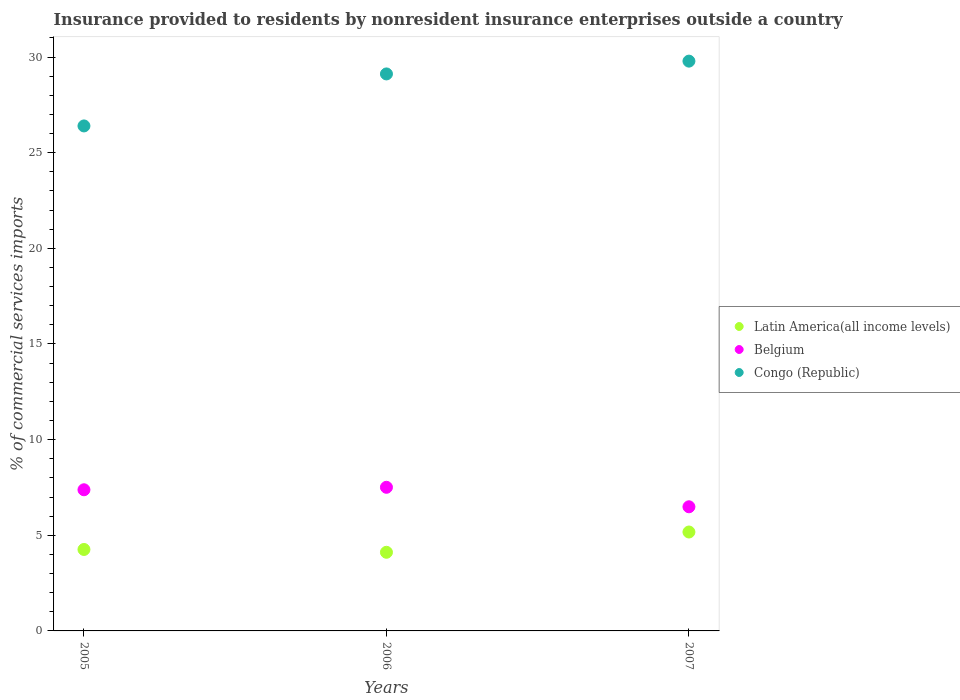How many different coloured dotlines are there?
Provide a short and direct response. 3. Is the number of dotlines equal to the number of legend labels?
Offer a terse response. Yes. What is the Insurance provided to residents in Latin America(all income levels) in 2005?
Your answer should be very brief. 4.26. Across all years, what is the maximum Insurance provided to residents in Belgium?
Your answer should be compact. 7.51. Across all years, what is the minimum Insurance provided to residents in Latin America(all income levels)?
Make the answer very short. 4.11. In which year was the Insurance provided to residents in Latin America(all income levels) maximum?
Provide a short and direct response. 2007. In which year was the Insurance provided to residents in Latin America(all income levels) minimum?
Keep it short and to the point. 2006. What is the total Insurance provided to residents in Congo (Republic) in the graph?
Your answer should be compact. 85.3. What is the difference between the Insurance provided to residents in Belgium in 2005 and that in 2007?
Your answer should be compact. 0.89. What is the difference between the Insurance provided to residents in Congo (Republic) in 2006 and the Insurance provided to residents in Latin America(all income levels) in 2005?
Offer a very short reply. 24.86. What is the average Insurance provided to residents in Belgium per year?
Make the answer very short. 7.13. In the year 2007, what is the difference between the Insurance provided to residents in Congo (Republic) and Insurance provided to residents in Latin America(all income levels)?
Your answer should be compact. 24.61. What is the ratio of the Insurance provided to residents in Latin America(all income levels) in 2005 to that in 2006?
Offer a very short reply. 1.04. What is the difference between the highest and the second highest Insurance provided to residents in Belgium?
Provide a short and direct response. 0.13. What is the difference between the highest and the lowest Insurance provided to residents in Latin America(all income levels)?
Make the answer very short. 1.06. In how many years, is the Insurance provided to residents in Congo (Republic) greater than the average Insurance provided to residents in Congo (Republic) taken over all years?
Provide a succinct answer. 2. Is the sum of the Insurance provided to residents in Congo (Republic) in 2005 and 2007 greater than the maximum Insurance provided to residents in Belgium across all years?
Offer a terse response. Yes. Is it the case that in every year, the sum of the Insurance provided to residents in Belgium and Insurance provided to residents in Latin America(all income levels)  is greater than the Insurance provided to residents in Congo (Republic)?
Make the answer very short. No. Is the Insurance provided to residents in Belgium strictly greater than the Insurance provided to residents in Congo (Republic) over the years?
Offer a terse response. No. Is the Insurance provided to residents in Latin America(all income levels) strictly less than the Insurance provided to residents in Congo (Republic) over the years?
Your answer should be compact. Yes. How many years are there in the graph?
Provide a succinct answer. 3. Are the values on the major ticks of Y-axis written in scientific E-notation?
Your answer should be compact. No. How many legend labels are there?
Your answer should be very brief. 3. What is the title of the graph?
Keep it short and to the point. Insurance provided to residents by nonresident insurance enterprises outside a country. Does "Micronesia" appear as one of the legend labels in the graph?
Offer a very short reply. No. What is the label or title of the X-axis?
Your answer should be very brief. Years. What is the label or title of the Y-axis?
Keep it short and to the point. % of commercial services imports. What is the % of commercial services imports in Latin America(all income levels) in 2005?
Your response must be concise. 4.26. What is the % of commercial services imports of Belgium in 2005?
Keep it short and to the point. 7.38. What is the % of commercial services imports in Congo (Republic) in 2005?
Offer a terse response. 26.4. What is the % of commercial services imports of Latin America(all income levels) in 2006?
Keep it short and to the point. 4.11. What is the % of commercial services imports of Belgium in 2006?
Make the answer very short. 7.51. What is the % of commercial services imports of Congo (Republic) in 2006?
Your answer should be compact. 29.12. What is the % of commercial services imports of Latin America(all income levels) in 2007?
Offer a very short reply. 5.17. What is the % of commercial services imports in Belgium in 2007?
Keep it short and to the point. 6.49. What is the % of commercial services imports in Congo (Republic) in 2007?
Offer a terse response. 29.78. Across all years, what is the maximum % of commercial services imports of Latin America(all income levels)?
Provide a short and direct response. 5.17. Across all years, what is the maximum % of commercial services imports in Belgium?
Give a very brief answer. 7.51. Across all years, what is the maximum % of commercial services imports of Congo (Republic)?
Your answer should be compact. 29.78. Across all years, what is the minimum % of commercial services imports in Latin America(all income levels)?
Keep it short and to the point. 4.11. Across all years, what is the minimum % of commercial services imports of Belgium?
Your answer should be very brief. 6.49. Across all years, what is the minimum % of commercial services imports of Congo (Republic)?
Your answer should be compact. 26.4. What is the total % of commercial services imports in Latin America(all income levels) in the graph?
Keep it short and to the point. 13.54. What is the total % of commercial services imports of Belgium in the graph?
Offer a very short reply. 21.38. What is the total % of commercial services imports in Congo (Republic) in the graph?
Offer a very short reply. 85.3. What is the difference between the % of commercial services imports of Latin America(all income levels) in 2005 and that in 2006?
Your answer should be compact. 0.15. What is the difference between the % of commercial services imports in Belgium in 2005 and that in 2006?
Your answer should be compact. -0.13. What is the difference between the % of commercial services imports in Congo (Republic) in 2005 and that in 2006?
Make the answer very short. -2.72. What is the difference between the % of commercial services imports of Latin America(all income levels) in 2005 and that in 2007?
Your response must be concise. -0.91. What is the difference between the % of commercial services imports of Belgium in 2005 and that in 2007?
Keep it short and to the point. 0.89. What is the difference between the % of commercial services imports of Congo (Republic) in 2005 and that in 2007?
Your answer should be compact. -3.39. What is the difference between the % of commercial services imports of Latin America(all income levels) in 2006 and that in 2007?
Your response must be concise. -1.06. What is the difference between the % of commercial services imports of Belgium in 2006 and that in 2007?
Offer a terse response. 1.02. What is the difference between the % of commercial services imports of Congo (Republic) in 2006 and that in 2007?
Give a very brief answer. -0.67. What is the difference between the % of commercial services imports in Latin America(all income levels) in 2005 and the % of commercial services imports in Belgium in 2006?
Provide a short and direct response. -3.25. What is the difference between the % of commercial services imports in Latin America(all income levels) in 2005 and the % of commercial services imports in Congo (Republic) in 2006?
Provide a short and direct response. -24.86. What is the difference between the % of commercial services imports of Belgium in 2005 and the % of commercial services imports of Congo (Republic) in 2006?
Your answer should be very brief. -21.74. What is the difference between the % of commercial services imports of Latin America(all income levels) in 2005 and the % of commercial services imports of Belgium in 2007?
Provide a succinct answer. -2.23. What is the difference between the % of commercial services imports in Latin America(all income levels) in 2005 and the % of commercial services imports in Congo (Republic) in 2007?
Your answer should be compact. -25.53. What is the difference between the % of commercial services imports of Belgium in 2005 and the % of commercial services imports of Congo (Republic) in 2007?
Offer a very short reply. -22.41. What is the difference between the % of commercial services imports in Latin America(all income levels) in 2006 and the % of commercial services imports in Belgium in 2007?
Make the answer very short. -2.38. What is the difference between the % of commercial services imports in Latin America(all income levels) in 2006 and the % of commercial services imports in Congo (Republic) in 2007?
Make the answer very short. -25.67. What is the difference between the % of commercial services imports in Belgium in 2006 and the % of commercial services imports in Congo (Republic) in 2007?
Ensure brevity in your answer.  -22.28. What is the average % of commercial services imports of Latin America(all income levels) per year?
Your answer should be compact. 4.51. What is the average % of commercial services imports of Belgium per year?
Provide a short and direct response. 7.13. What is the average % of commercial services imports in Congo (Republic) per year?
Offer a very short reply. 28.43. In the year 2005, what is the difference between the % of commercial services imports of Latin America(all income levels) and % of commercial services imports of Belgium?
Keep it short and to the point. -3.12. In the year 2005, what is the difference between the % of commercial services imports in Latin America(all income levels) and % of commercial services imports in Congo (Republic)?
Make the answer very short. -22.14. In the year 2005, what is the difference between the % of commercial services imports of Belgium and % of commercial services imports of Congo (Republic)?
Your answer should be very brief. -19.02. In the year 2006, what is the difference between the % of commercial services imports in Latin America(all income levels) and % of commercial services imports in Belgium?
Provide a succinct answer. -3.4. In the year 2006, what is the difference between the % of commercial services imports of Latin America(all income levels) and % of commercial services imports of Congo (Republic)?
Provide a succinct answer. -25. In the year 2006, what is the difference between the % of commercial services imports in Belgium and % of commercial services imports in Congo (Republic)?
Your answer should be compact. -21.61. In the year 2007, what is the difference between the % of commercial services imports of Latin America(all income levels) and % of commercial services imports of Belgium?
Your response must be concise. -1.32. In the year 2007, what is the difference between the % of commercial services imports in Latin America(all income levels) and % of commercial services imports in Congo (Republic)?
Make the answer very short. -24.61. In the year 2007, what is the difference between the % of commercial services imports in Belgium and % of commercial services imports in Congo (Republic)?
Offer a very short reply. -23.3. What is the ratio of the % of commercial services imports in Latin America(all income levels) in 2005 to that in 2006?
Ensure brevity in your answer.  1.04. What is the ratio of the % of commercial services imports in Belgium in 2005 to that in 2006?
Offer a very short reply. 0.98. What is the ratio of the % of commercial services imports of Congo (Republic) in 2005 to that in 2006?
Ensure brevity in your answer.  0.91. What is the ratio of the % of commercial services imports in Latin America(all income levels) in 2005 to that in 2007?
Offer a terse response. 0.82. What is the ratio of the % of commercial services imports of Belgium in 2005 to that in 2007?
Your answer should be very brief. 1.14. What is the ratio of the % of commercial services imports of Congo (Republic) in 2005 to that in 2007?
Provide a succinct answer. 0.89. What is the ratio of the % of commercial services imports of Latin America(all income levels) in 2006 to that in 2007?
Ensure brevity in your answer.  0.8. What is the ratio of the % of commercial services imports of Belgium in 2006 to that in 2007?
Provide a succinct answer. 1.16. What is the ratio of the % of commercial services imports of Congo (Republic) in 2006 to that in 2007?
Keep it short and to the point. 0.98. What is the difference between the highest and the second highest % of commercial services imports of Latin America(all income levels)?
Provide a succinct answer. 0.91. What is the difference between the highest and the second highest % of commercial services imports in Belgium?
Give a very brief answer. 0.13. What is the difference between the highest and the second highest % of commercial services imports of Congo (Republic)?
Offer a terse response. 0.67. What is the difference between the highest and the lowest % of commercial services imports in Latin America(all income levels)?
Provide a succinct answer. 1.06. What is the difference between the highest and the lowest % of commercial services imports of Belgium?
Make the answer very short. 1.02. What is the difference between the highest and the lowest % of commercial services imports of Congo (Republic)?
Make the answer very short. 3.39. 